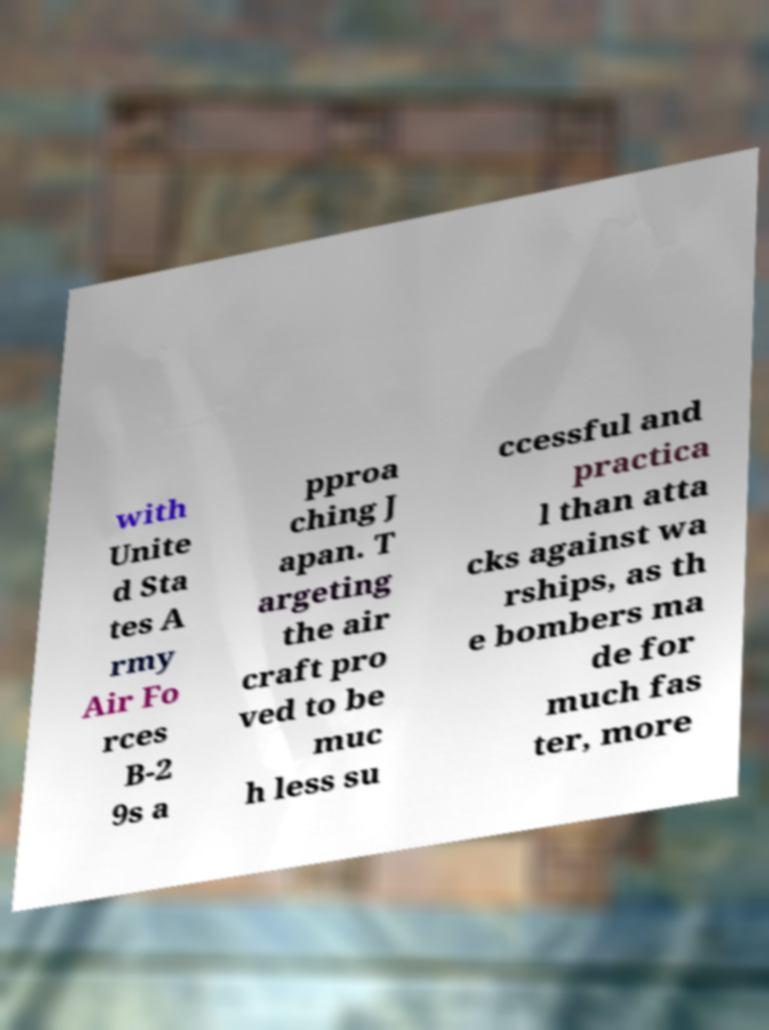For documentation purposes, I need the text within this image transcribed. Could you provide that? with Unite d Sta tes A rmy Air Fo rces B-2 9s a pproa ching J apan. T argeting the air craft pro ved to be muc h less su ccessful and practica l than atta cks against wa rships, as th e bombers ma de for much fas ter, more 